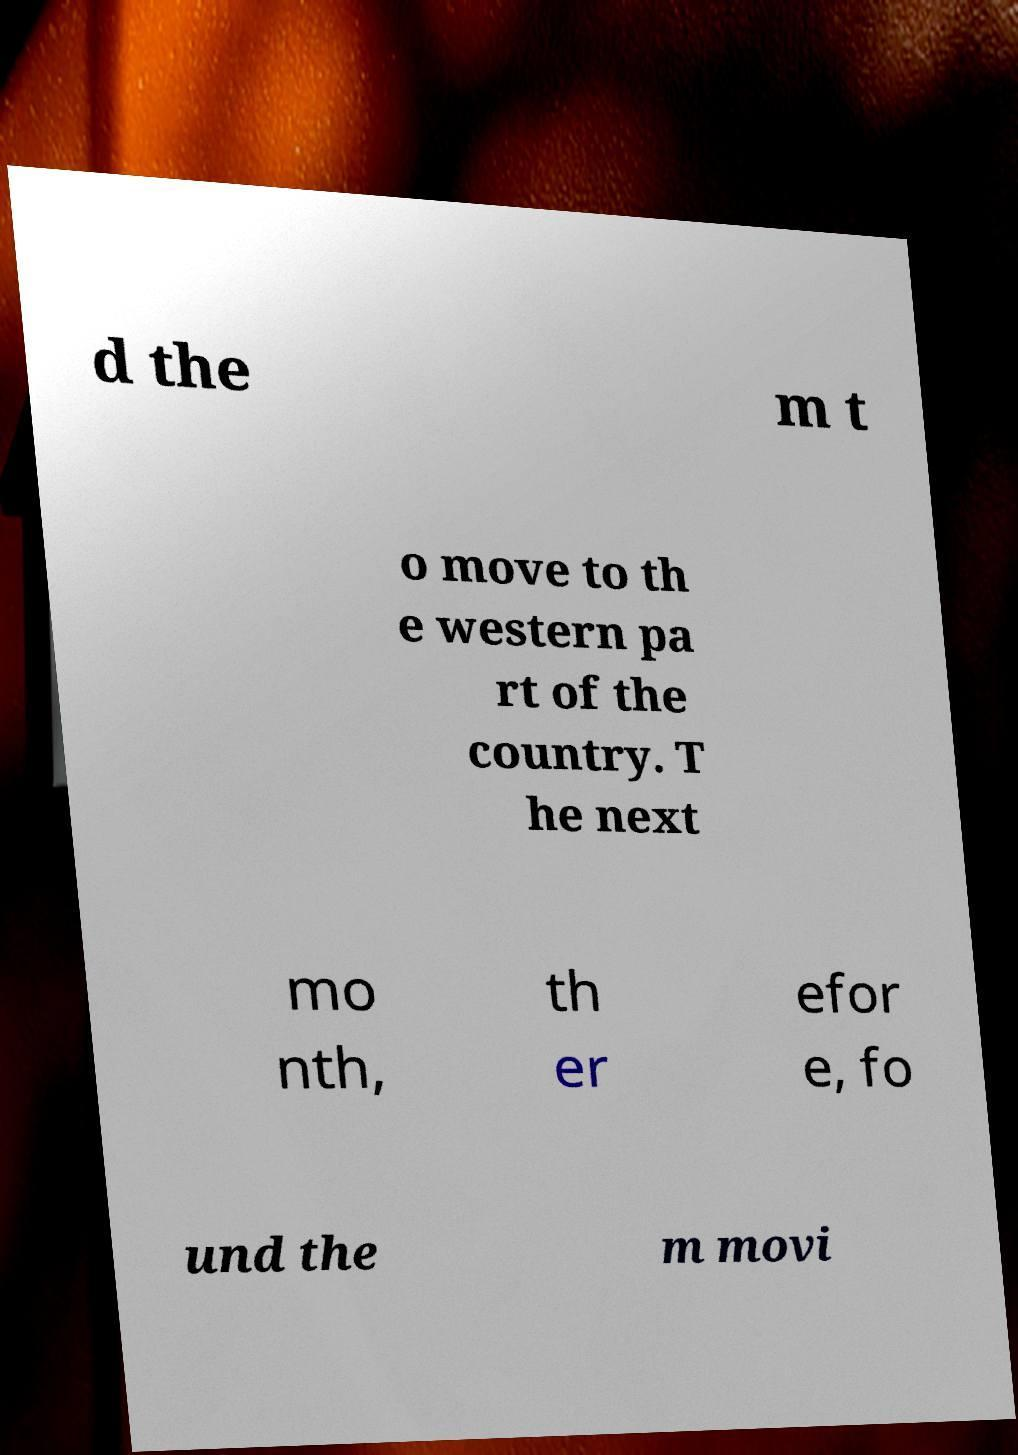Could you assist in decoding the text presented in this image and type it out clearly? d the m t o move to th e western pa rt of the country. T he next mo nth, th er efor e, fo und the m movi 